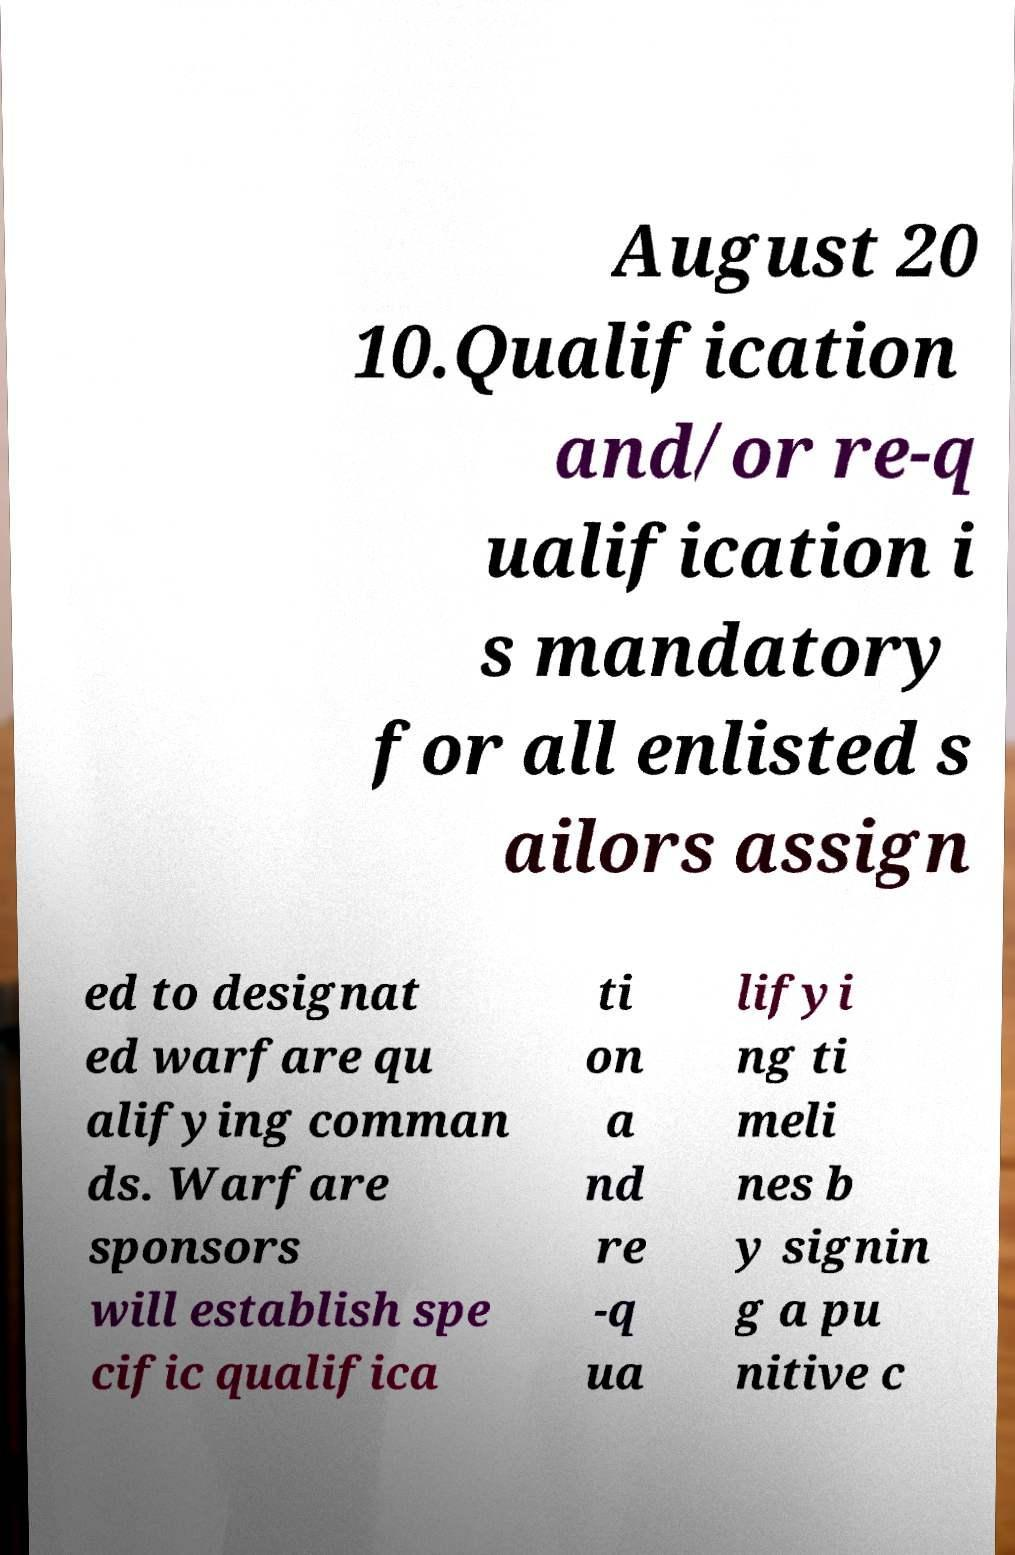Can you accurately transcribe the text from the provided image for me? August 20 10.Qualification and/or re-q ualification i s mandatory for all enlisted s ailors assign ed to designat ed warfare qu alifying comman ds. Warfare sponsors will establish spe cific qualifica ti on a nd re -q ua lifyi ng ti meli nes b y signin g a pu nitive c 